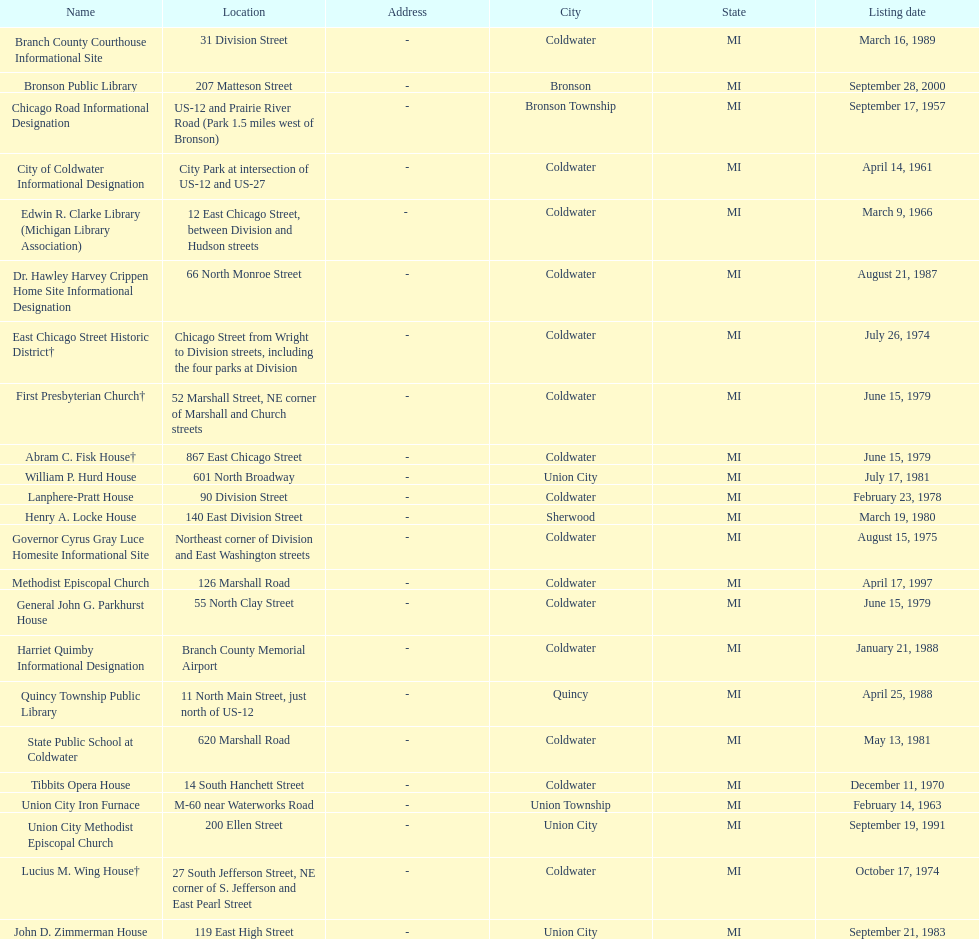What are all of the locations considered historical sites in branch county, michigan? Branch County Courthouse Informational Site, Bronson Public Library, Chicago Road Informational Designation, City of Coldwater Informational Designation, Edwin R. Clarke Library (Michigan Library Association), Dr. Hawley Harvey Crippen Home Site Informational Designation, East Chicago Street Historic District†, First Presbyterian Church†, Abram C. Fisk House†, William P. Hurd House, Lanphere-Pratt House, Henry A. Locke House, Governor Cyrus Gray Luce Homesite Informational Site, Methodist Episcopal Church, General John G. Parkhurst House, Harriet Quimby Informational Designation, Quincy Township Public Library, State Public School at Coldwater, Tibbits Opera House, Union City Iron Furnace, Union City Methodist Episcopal Church, Lucius M. Wing House†, John D. Zimmerman House. Of those sites, which one was the first to be listed as historical? Chicago Road Informational Designation. 